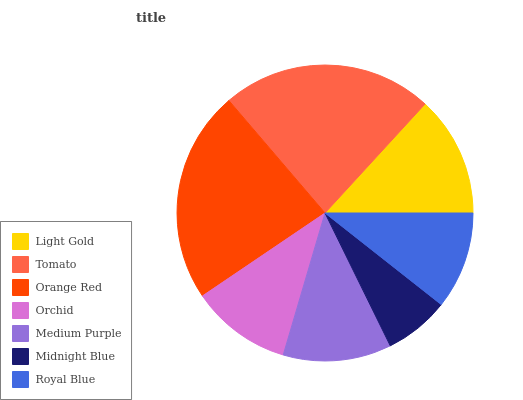Is Midnight Blue the minimum?
Answer yes or no. Yes. Is Orange Red the maximum?
Answer yes or no. Yes. Is Tomato the minimum?
Answer yes or no. No. Is Tomato the maximum?
Answer yes or no. No. Is Tomato greater than Light Gold?
Answer yes or no. Yes. Is Light Gold less than Tomato?
Answer yes or no. Yes. Is Light Gold greater than Tomato?
Answer yes or no. No. Is Tomato less than Light Gold?
Answer yes or no. No. Is Medium Purple the high median?
Answer yes or no. Yes. Is Medium Purple the low median?
Answer yes or no. Yes. Is Light Gold the high median?
Answer yes or no. No. Is Light Gold the low median?
Answer yes or no. No. 